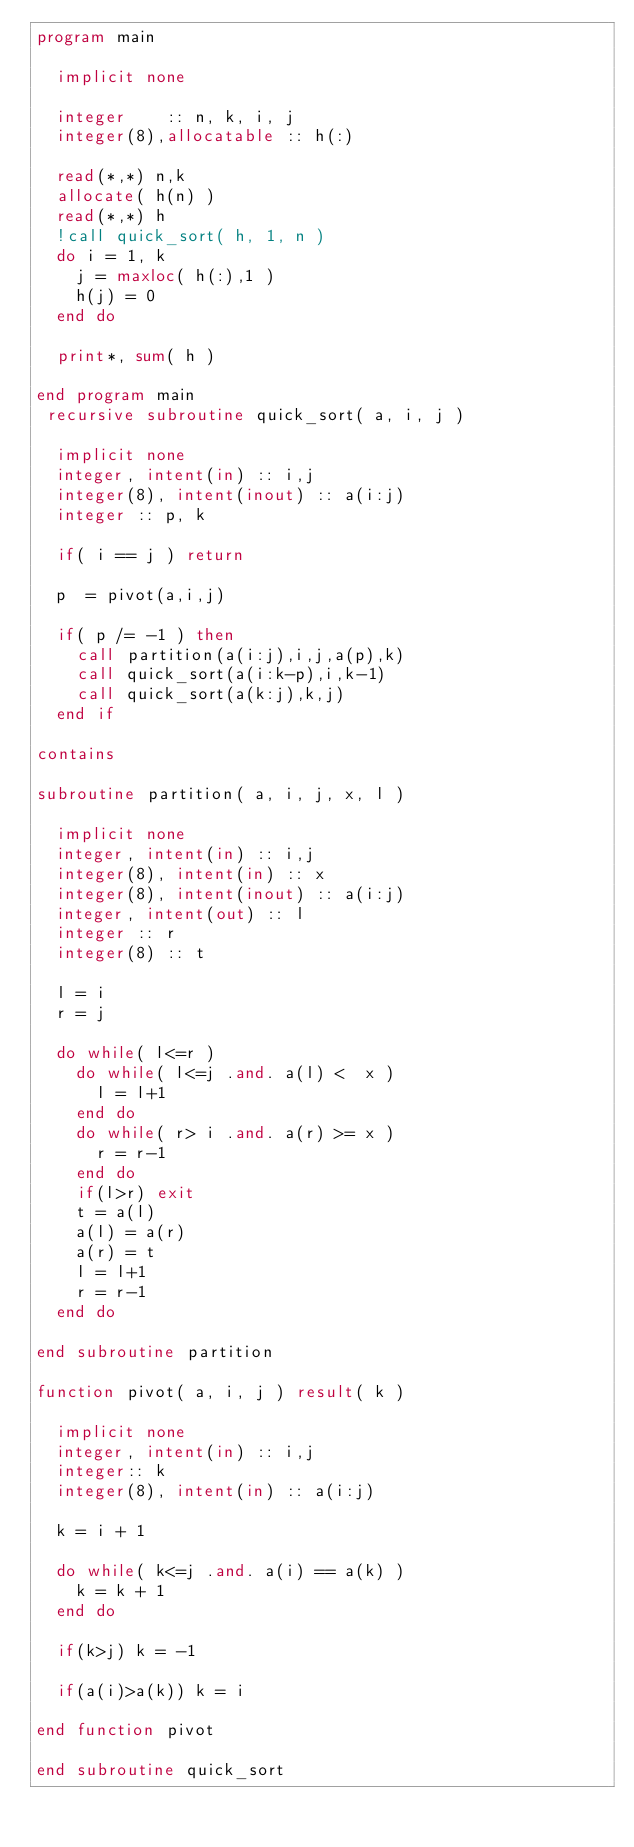Convert code to text. <code><loc_0><loc_0><loc_500><loc_500><_FORTRAN_>program main

  implicit none

  integer    :: n, k, i, j
  integer(8),allocatable :: h(:)
  
  read(*,*) n,k
  allocate( h(n) )
  read(*,*) h
  !call quick_sort( h, 1, n ) 
  do i = 1, k 
    j = maxloc( h(:),1 )
    h(j) = 0
  end do
  
  print*, sum( h ) 

end program main
 recursive subroutine quick_sort( a, i, j )

  implicit none
  integer, intent(in) :: i,j
  integer(8), intent(inout) :: a(i:j)
  integer :: p, k

  if( i == j ) return
 
  p  = pivot(a,i,j)
 
  if( p /= -1 ) then
    call partition(a(i:j),i,j,a(p),k)
    call quick_sort(a(i:k-p),i,k-1)
    call quick_sort(a(k:j),k,j)
  end if

contains 

subroutine partition( a, i, j, x, l ) 
  
  implicit none
  integer, intent(in) :: i,j
  integer(8), intent(in) :: x
  integer(8), intent(inout) :: a(i:j)
  integer, intent(out) :: l
  integer :: r
  integer(8) :: t
   
  l = i 
  r = j 

  do while( l<=r )
    do while( l<=j .and. a(l) <  x ) 
      l = l+1
    end do
    do while( r> i .and. a(r) >= x ) 
      r = r-1
    end do
    if(l>r) exit
    t = a(l)
    a(l) = a(r)
    a(r) = t
    l = l+1
    r = r-1
  end do
  
end subroutine partition

function pivot( a, i, j ) result( k )

  implicit none
  integer, intent(in) :: i,j
  integer:: k
  integer(8), intent(in) :: a(i:j)

  k = i + 1

  do while( k<=j .and. a(i) == a(k) ) 
    k = k + 1
  end do

  if(k>j) k = -1

  if(a(i)>a(k)) k = i

end function pivot

end subroutine quick_sort 

</code> 